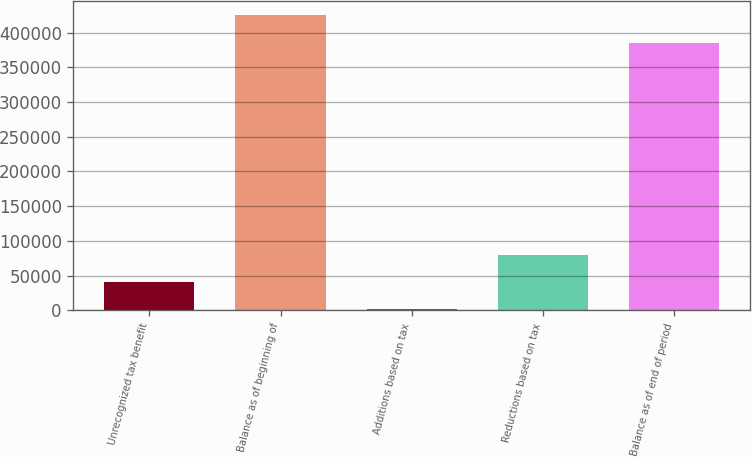<chart> <loc_0><loc_0><loc_500><loc_500><bar_chart><fcel>Unrecognized tax benefit<fcel>Balance as of beginning of<fcel>Additions based on tax<fcel>Reductions based on tax<fcel>Balance as of end of period<nl><fcel>40894.6<fcel>424619<fcel>1670<fcel>80119.2<fcel>385394<nl></chart> 